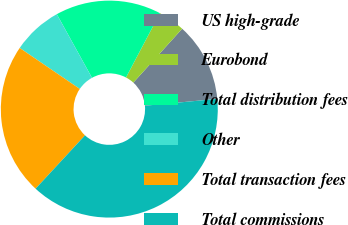Convert chart. <chart><loc_0><loc_0><loc_500><loc_500><pie_chart><fcel>US high-grade<fcel>Eurobond<fcel>Total distribution fees<fcel>Other<fcel>Total transaction fees<fcel>Total commissions<nl><fcel>11.78%<fcel>3.99%<fcel>15.77%<fcel>7.43%<fcel>22.64%<fcel>38.4%<nl></chart> 